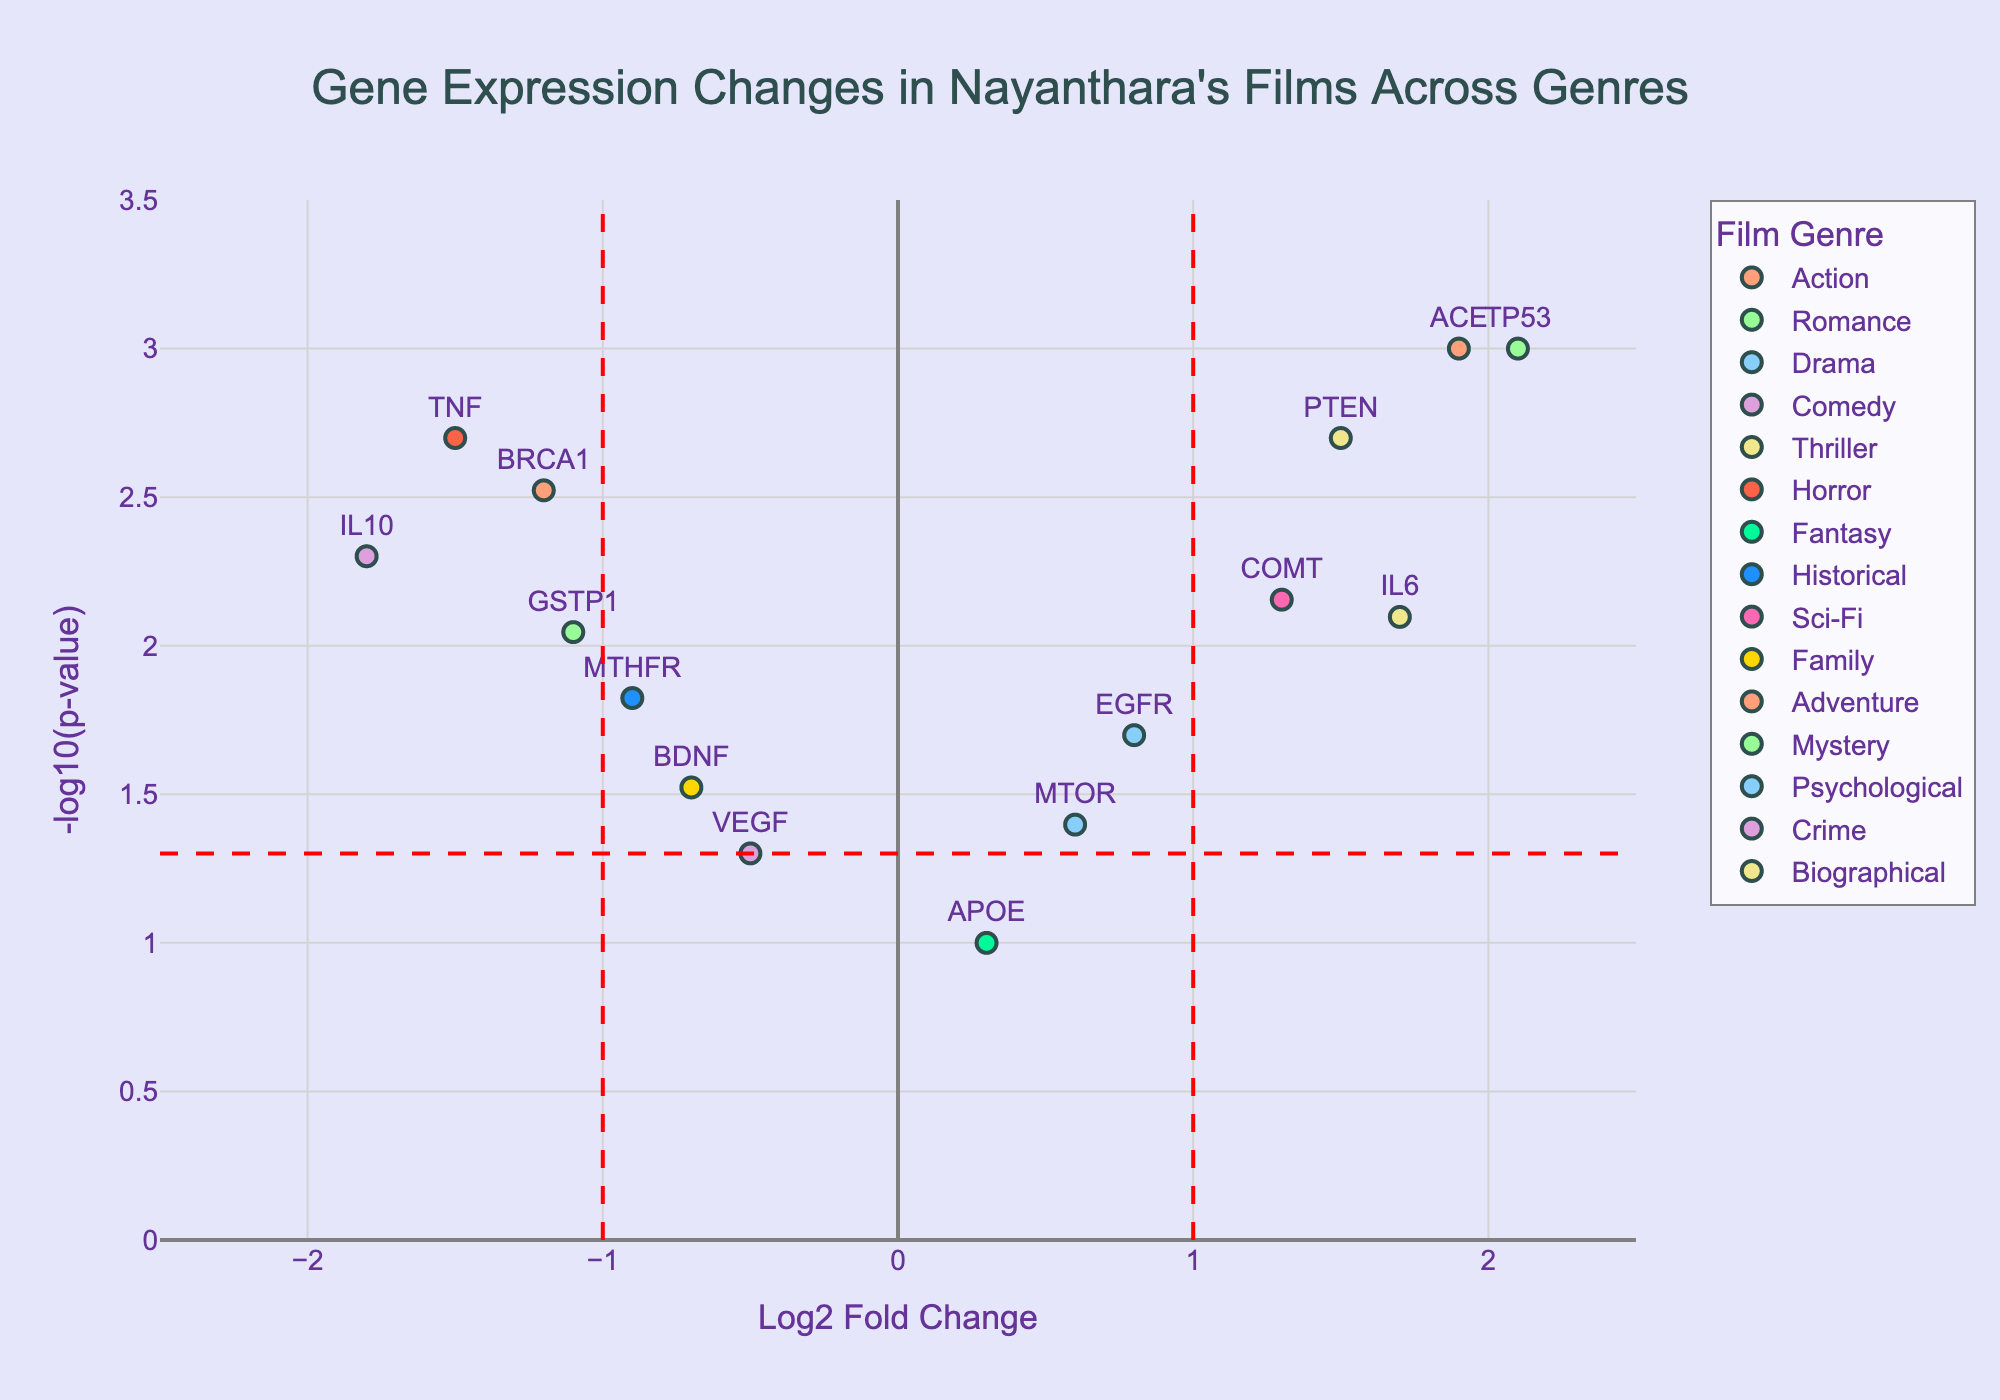How many genres are represented in the plot? By observing the legend of the plot which lists the categories of film genres
Answer: 15 What's the log2 fold change for the gene BRCA1? Look at the horizontal axis which represents the log2 fold change, find the label for BRCA1 and read its position along the x-axis
Answer: -1.2 Which gene is associated with the highest -log10(p-value)? Locate the point that is located at the highest point on the vertical axis which represents the -log10(p-value), and then identify the gene label at that point
Answer: TP53 What is the range displayed on the x-axis for log2 fold change? Check the tick labels on the x-axis which show the minimum and maximum values
Answer: -2.5 to 2.5 Which genre has a gene with a log2 fold change greater than 1 and a -log10(p-value) greater than 2? Identify points in the upper right quadrant, then follow the hover information or legend to determine the genre
Answer: Romance, Adventure, Biographical Which gene has a -log10(p-value) at the borderline significance level of 1.3? Look for points on the plot that are positioned at the horizontal line indicating -log10(p-value) = 1.3 and identify the gene label
Answer: VEGF How many genes have a log2 fold change less than -1? Count the points located to the left of the vertical red dashed line at log2 fold change = -1
Answer: 4 What is the color associated with Psychological genre and which gene belongs to it? Refer to the legend for the color associated with the Psychological genre and locate the corresponding point in the plot to get the gene label
Answer: Light blue; MTOR Which genes have a p-value less than 0.01? Locate the points that lie above the horizontal line at -log10(p-value) = 2, indicating p-values less than 0.01, then identify the gene labels
Answer: BRCA1, TP53, IL6, TNF, GSTP1, IL10, PTEN What value of the log2 fold change is associated with the gene APOE? Find the gene APOE and read its position value on the x-axis
Answer: 0.3 